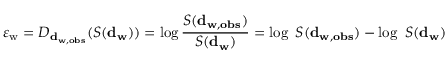Convert formula to latex. <formula><loc_0><loc_0><loc_500><loc_500>\varepsilon _ { w } = D _ { d _ { w , o b s } } ( { S ( d } _ { w } ) ) = \log \frac { { S ( d } _ { w , o b s } ) } { { S ( d } _ { w } ) } = \log { \ S ( d } _ { w , o b s } ) - \log \ { S ( d } _ { w } ) \</formula> 